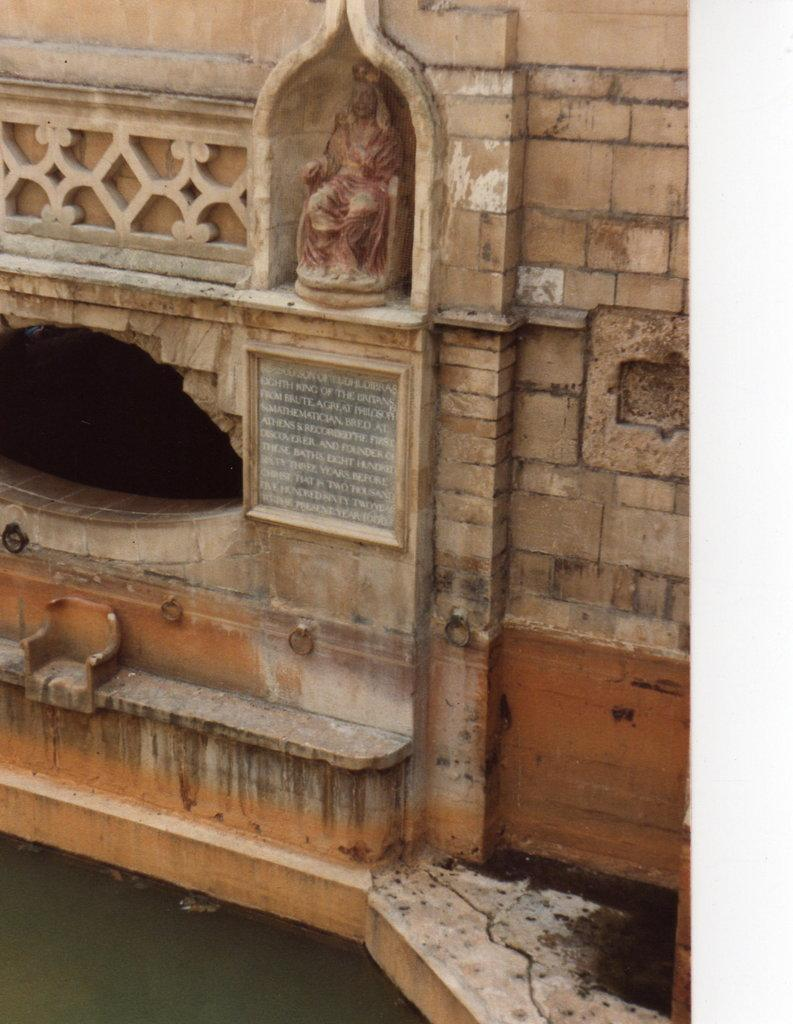What is present on the wall in the image? There is a board attached to the wall in the image. What can be found on the board? The board has text on it and a sculpture at the top. What is the price of the quiver hanging on the wall in the image? There is no quiver present in the image, so it is not possible to determine its price. 